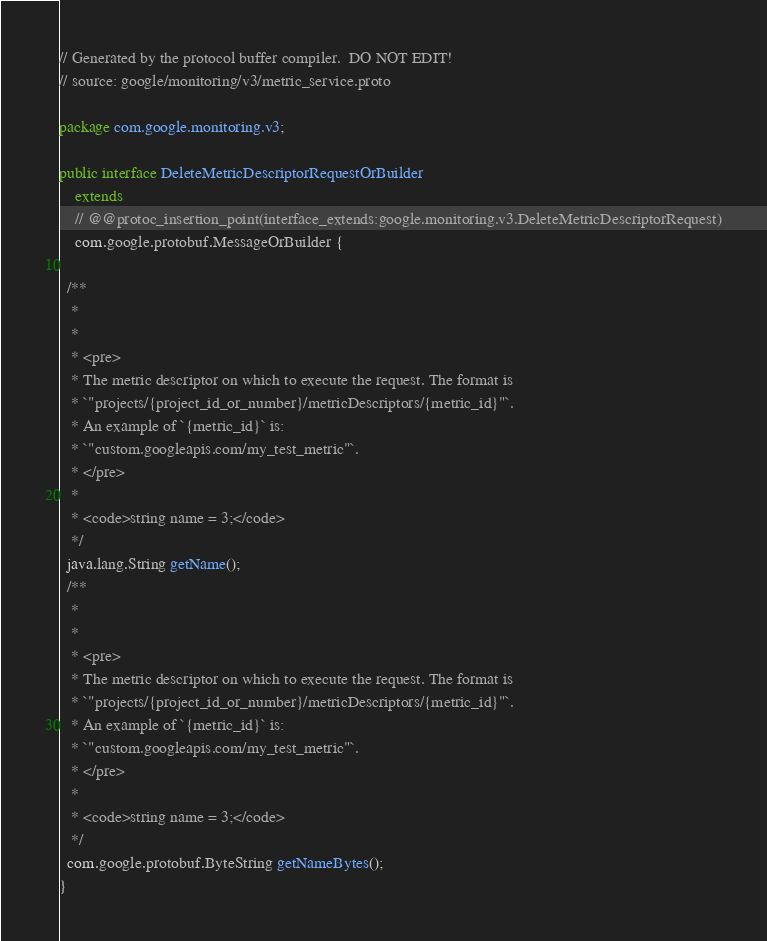<code> <loc_0><loc_0><loc_500><loc_500><_Java_>// Generated by the protocol buffer compiler.  DO NOT EDIT!
// source: google/monitoring/v3/metric_service.proto

package com.google.monitoring.v3;

public interface DeleteMetricDescriptorRequestOrBuilder
    extends
    // @@protoc_insertion_point(interface_extends:google.monitoring.v3.DeleteMetricDescriptorRequest)
    com.google.protobuf.MessageOrBuilder {

  /**
   *
   *
   * <pre>
   * The metric descriptor on which to execute the request. The format is
   * `"projects/{project_id_or_number}/metricDescriptors/{metric_id}"`.
   * An example of `{metric_id}` is:
   * `"custom.googleapis.com/my_test_metric"`.
   * </pre>
   *
   * <code>string name = 3;</code>
   */
  java.lang.String getName();
  /**
   *
   *
   * <pre>
   * The metric descriptor on which to execute the request. The format is
   * `"projects/{project_id_or_number}/metricDescriptors/{metric_id}"`.
   * An example of `{metric_id}` is:
   * `"custom.googleapis.com/my_test_metric"`.
   * </pre>
   *
   * <code>string name = 3;</code>
   */
  com.google.protobuf.ByteString getNameBytes();
}
</code> 